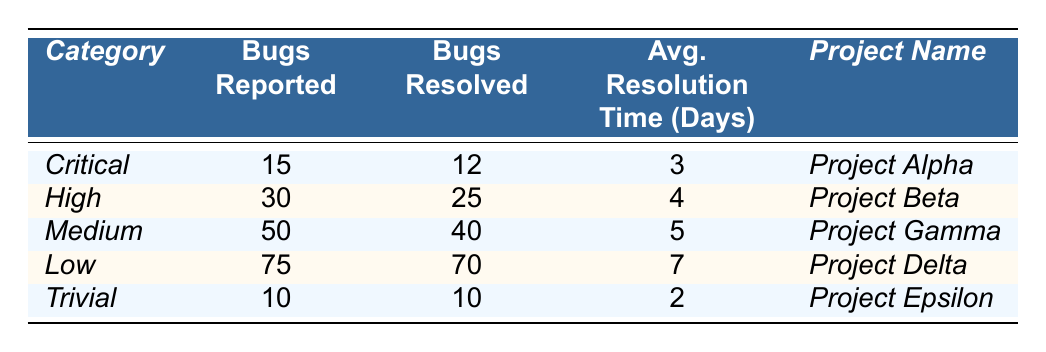What is the total number of bugs reported across all categories? To find the total number of bugs reported, we sum the bugs reported in each category: 15 (Critical) + 30 (High) + 50 (Medium) + 75 (Low) + 10 (Trivial) = 180.
Answer: 180 Which project has the highest number of bugs resolved? The project with the highest number of bugs resolved is Project Delta, which resolved 70 bugs.
Answer: Project Delta What is the average resolution time for bugs in the High category? The average resolution time for the High category is given as 4 days directly in the table.
Answer: 4 days In which project was the lowest average resolution time observed? The lowest average resolution time is found in Project Epsilon, which had an average resolution time of 2 days.
Answer: Project Epsilon How many more bugs were reported in the Medium category compared to the Trivial category? The difference in bugs reported between the Medium category (50) and the Trivial category (10) is 50 - 10 = 40.
Answer: 40 Is the number of bugs resolved in the Critical category greater than the number of bugs reported in the Low category? In the Critical category, 12 bugs were resolved, while in the Low category, 75 bugs were reported. Since 12 is less than 75, the answer is no.
Answer: No What is the total number of bugs resolved across all projects? To find the total number of bugs resolved, we sum the bugs resolved in each category: 12 (Critical) + 25 (High) + 40 (Medium) + 70 (Low) + 10 (Trivial) = 167.
Answer: 167 Which category had the highest average resolution time, and what was that time? The category with the highest average resolution time is the Low category, with an average resolution time of 7 days.
Answer: Low category, 7 days What percentage of bugs were resolved in the Medium category? In the Medium category, 40 bugs were resolved out of 50 reported. The percentage resolved is (40/50) * 100 = 80%.
Answer: 80% If we only consider the Critical and High categories, how many bugs were reported and how many were resolved? In the Critical category, 15 bugs were reported and 12 were resolved. In the High category, 30 were reported and 25 were resolved. Total reported = 15 + 30 = 45, and total resolved = 12 + 25 = 37.
Answer: Reported: 45, Resolved: 37 